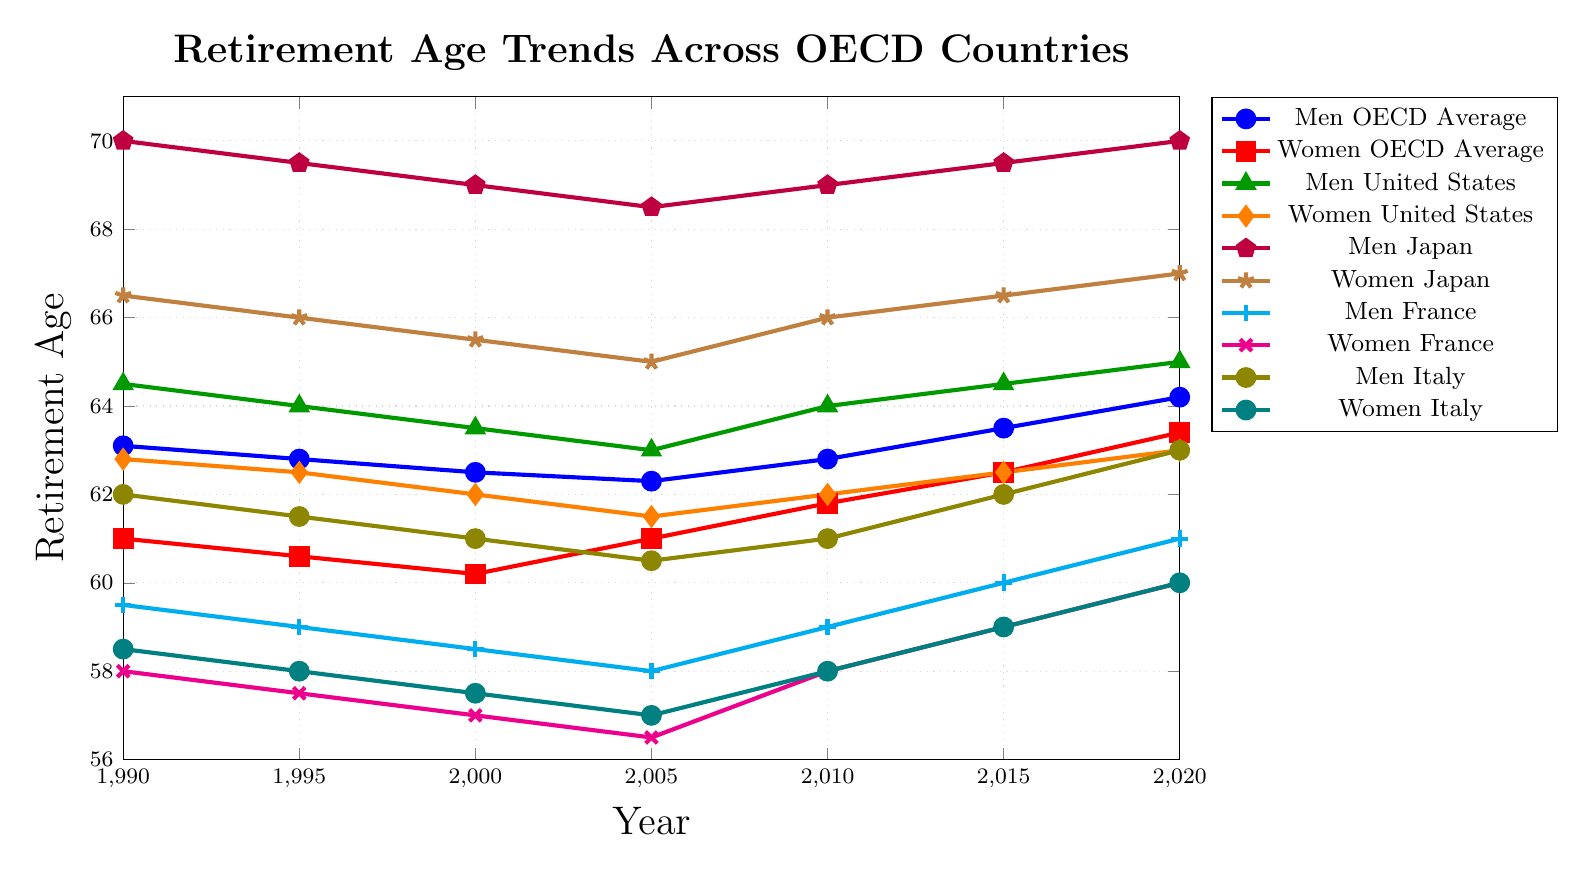What is the average retirement age for Men OECD Average in the years 1990 and 2020? First, find the retirement ages for Men OECD Average in 1990 and 2020, which are 63.1 and 64.2, respectively. Add these two values (63.1 + 64.2 = 127.3). Finally, divide by 2 to find the average: 127.3 / 2 = 63.65.
Answer: 63.65 Which country's women have the highest retirement age in 2020? Look at the retirement ages for women in the legend entries and compare their values in 2020: OECD Average (63.4), United States (63.0), Japan (67.0), France (60.0), Italy (60.0). The highest value is for Japan at 67.0.
Answer: Japan In which year did Women France and Men Italy have the same retirement age? Look at the lines for Women France (magenta) and Men Italy (olive) and identify the year where both lines meet. The lines intersect in 2010, where both have a retirement age of 61.0.
Answer: 2010 How did the retirement age for Men Japan change from 1990 to 2020? Find the retirement ages for Men Japan in 1990 and 2020, which are 70.0 and 70.0 respectively. Subtract the 1990 value from the 2020 value: 70.0 - 70.0 = 0. There was no change.
Answer: 0 Which country had the biggest increase in retirement age for women from 1990 to 2020? Calculate the difference in retirement ages from 1990 to 2020 for each country: OECD Average (63.4 - 61.0 = 2.4), United States (63.0 - 62.8 = 0.2), Japan (67.0 - 66.5 = 0.5), France (60.0 - 58.0 = 2.0), Italy (60.0 - 58.5 = 1.5). The OECD Average shows the biggest increase (2.4).
Answer: OECD Average What is the difference in retirement age between Men and Women in France in 2020? Look at the retirement ages for Men and Women in France in 2020, which are 61.0 and 60.0, respectively. Subtract the woman's value from the man's value: 61.0 - 60.0 = 1.0.
Answer: 1.0 By how much did the retirement age for Women OECD Average increase from 1990 to 2010? Find the retirement ages for Women OECD Average in 1990 and 2010, which are 61.0 and 61.8, respectively. Subtract the 1990 value from the 2010 value: 61.8 - 61.0 = 0.8.
Answer: 0.8 Compare the retirement age trends for Men and Women in the United States from 1990 to 2020. Who had a greater overall increase? Determine the change in retirement age for Men and Women in the United States from 1990 to 2020: Men (65.0 - 64.5 = 0.5) and Women (63.0 - 62.8 = 0.2). Men had a greater increase of 0.5 compared to 0.2 for Women.
Answer: Men 